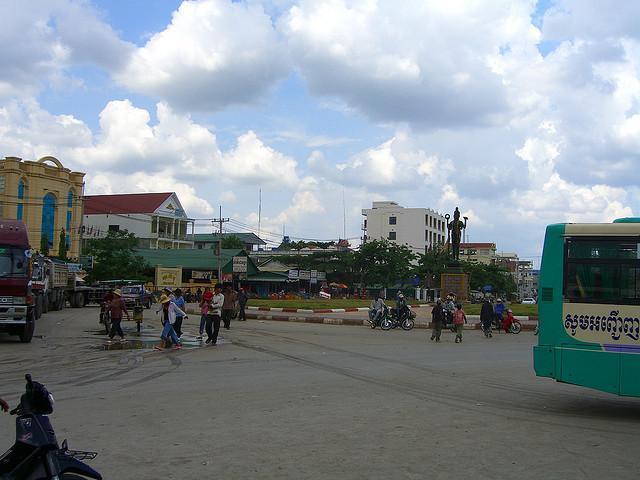How many buses are in the parking lot?
Give a very brief answer. 1. How many yellow signs are in the photo?
Give a very brief answer. 1. How many trucks are in the photo?
Give a very brief answer. 2. 